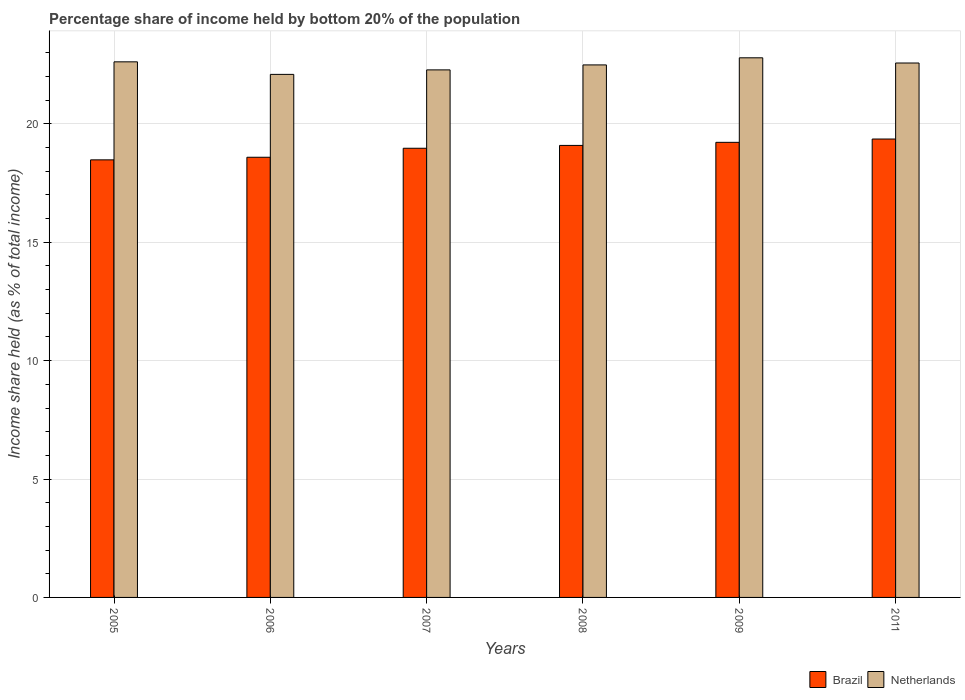How many groups of bars are there?
Provide a succinct answer. 6. Are the number of bars per tick equal to the number of legend labels?
Make the answer very short. Yes. Are the number of bars on each tick of the X-axis equal?
Your answer should be very brief. Yes. What is the label of the 2nd group of bars from the left?
Keep it short and to the point. 2006. In how many cases, is the number of bars for a given year not equal to the number of legend labels?
Provide a succinct answer. 0. What is the share of income held by bottom 20% of the population in Netherlands in 2011?
Make the answer very short. 22.57. Across all years, what is the maximum share of income held by bottom 20% of the population in Netherlands?
Ensure brevity in your answer.  22.79. Across all years, what is the minimum share of income held by bottom 20% of the population in Netherlands?
Your response must be concise. 22.09. In which year was the share of income held by bottom 20% of the population in Netherlands minimum?
Offer a terse response. 2006. What is the total share of income held by bottom 20% of the population in Brazil in the graph?
Provide a short and direct response. 113.71. What is the difference between the share of income held by bottom 20% of the population in Netherlands in 2007 and that in 2008?
Make the answer very short. -0.21. What is the difference between the share of income held by bottom 20% of the population in Netherlands in 2008 and the share of income held by bottom 20% of the population in Brazil in 2005?
Provide a short and direct response. 4.01. What is the average share of income held by bottom 20% of the population in Brazil per year?
Ensure brevity in your answer.  18.95. In how many years, is the share of income held by bottom 20% of the population in Brazil greater than 12 %?
Your response must be concise. 6. What is the ratio of the share of income held by bottom 20% of the population in Netherlands in 2005 to that in 2006?
Give a very brief answer. 1.02. Is the share of income held by bottom 20% of the population in Brazil in 2006 less than that in 2009?
Your answer should be compact. Yes. What is the difference between the highest and the second highest share of income held by bottom 20% of the population in Netherlands?
Make the answer very short. 0.17. What is the difference between the highest and the lowest share of income held by bottom 20% of the population in Netherlands?
Offer a very short reply. 0.7. In how many years, is the share of income held by bottom 20% of the population in Netherlands greater than the average share of income held by bottom 20% of the population in Netherlands taken over all years?
Your response must be concise. 4. What does the 2nd bar from the left in 2009 represents?
Provide a succinct answer. Netherlands. How many bars are there?
Offer a very short reply. 12. Are all the bars in the graph horizontal?
Keep it short and to the point. No. How many years are there in the graph?
Provide a short and direct response. 6. Does the graph contain grids?
Offer a very short reply. Yes. Where does the legend appear in the graph?
Ensure brevity in your answer.  Bottom right. How many legend labels are there?
Your answer should be very brief. 2. How are the legend labels stacked?
Give a very brief answer. Horizontal. What is the title of the graph?
Ensure brevity in your answer.  Percentage share of income held by bottom 20% of the population. Does "South Asia" appear as one of the legend labels in the graph?
Make the answer very short. No. What is the label or title of the X-axis?
Make the answer very short. Years. What is the label or title of the Y-axis?
Your answer should be very brief. Income share held (as % of total income). What is the Income share held (as % of total income) of Brazil in 2005?
Make the answer very short. 18.48. What is the Income share held (as % of total income) of Netherlands in 2005?
Give a very brief answer. 22.62. What is the Income share held (as % of total income) of Brazil in 2006?
Provide a succinct answer. 18.59. What is the Income share held (as % of total income) of Netherlands in 2006?
Your answer should be very brief. 22.09. What is the Income share held (as % of total income) in Brazil in 2007?
Offer a very short reply. 18.97. What is the Income share held (as % of total income) of Netherlands in 2007?
Your answer should be very brief. 22.28. What is the Income share held (as % of total income) of Brazil in 2008?
Your response must be concise. 19.09. What is the Income share held (as % of total income) in Netherlands in 2008?
Your answer should be very brief. 22.49. What is the Income share held (as % of total income) of Brazil in 2009?
Your answer should be compact. 19.22. What is the Income share held (as % of total income) of Netherlands in 2009?
Give a very brief answer. 22.79. What is the Income share held (as % of total income) of Brazil in 2011?
Make the answer very short. 19.36. What is the Income share held (as % of total income) of Netherlands in 2011?
Your response must be concise. 22.57. Across all years, what is the maximum Income share held (as % of total income) in Brazil?
Give a very brief answer. 19.36. Across all years, what is the maximum Income share held (as % of total income) in Netherlands?
Offer a terse response. 22.79. Across all years, what is the minimum Income share held (as % of total income) in Brazil?
Your response must be concise. 18.48. Across all years, what is the minimum Income share held (as % of total income) in Netherlands?
Make the answer very short. 22.09. What is the total Income share held (as % of total income) of Brazil in the graph?
Your response must be concise. 113.71. What is the total Income share held (as % of total income) of Netherlands in the graph?
Ensure brevity in your answer.  134.84. What is the difference between the Income share held (as % of total income) in Brazil in 2005 and that in 2006?
Keep it short and to the point. -0.11. What is the difference between the Income share held (as % of total income) of Netherlands in 2005 and that in 2006?
Provide a short and direct response. 0.53. What is the difference between the Income share held (as % of total income) of Brazil in 2005 and that in 2007?
Offer a terse response. -0.49. What is the difference between the Income share held (as % of total income) of Netherlands in 2005 and that in 2007?
Keep it short and to the point. 0.34. What is the difference between the Income share held (as % of total income) in Brazil in 2005 and that in 2008?
Your response must be concise. -0.61. What is the difference between the Income share held (as % of total income) in Netherlands in 2005 and that in 2008?
Offer a terse response. 0.13. What is the difference between the Income share held (as % of total income) in Brazil in 2005 and that in 2009?
Give a very brief answer. -0.74. What is the difference between the Income share held (as % of total income) in Netherlands in 2005 and that in 2009?
Offer a very short reply. -0.17. What is the difference between the Income share held (as % of total income) of Brazil in 2005 and that in 2011?
Your answer should be very brief. -0.88. What is the difference between the Income share held (as % of total income) in Netherlands in 2005 and that in 2011?
Offer a very short reply. 0.05. What is the difference between the Income share held (as % of total income) of Brazil in 2006 and that in 2007?
Make the answer very short. -0.38. What is the difference between the Income share held (as % of total income) in Netherlands in 2006 and that in 2007?
Your answer should be compact. -0.19. What is the difference between the Income share held (as % of total income) in Brazil in 2006 and that in 2008?
Give a very brief answer. -0.5. What is the difference between the Income share held (as % of total income) in Netherlands in 2006 and that in 2008?
Make the answer very short. -0.4. What is the difference between the Income share held (as % of total income) in Brazil in 2006 and that in 2009?
Make the answer very short. -0.63. What is the difference between the Income share held (as % of total income) of Netherlands in 2006 and that in 2009?
Your answer should be very brief. -0.7. What is the difference between the Income share held (as % of total income) of Brazil in 2006 and that in 2011?
Make the answer very short. -0.77. What is the difference between the Income share held (as % of total income) of Netherlands in 2006 and that in 2011?
Provide a short and direct response. -0.48. What is the difference between the Income share held (as % of total income) in Brazil in 2007 and that in 2008?
Your answer should be very brief. -0.12. What is the difference between the Income share held (as % of total income) of Netherlands in 2007 and that in 2008?
Your response must be concise. -0.21. What is the difference between the Income share held (as % of total income) of Brazil in 2007 and that in 2009?
Provide a short and direct response. -0.25. What is the difference between the Income share held (as % of total income) of Netherlands in 2007 and that in 2009?
Provide a short and direct response. -0.51. What is the difference between the Income share held (as % of total income) of Brazil in 2007 and that in 2011?
Keep it short and to the point. -0.39. What is the difference between the Income share held (as % of total income) in Netherlands in 2007 and that in 2011?
Ensure brevity in your answer.  -0.29. What is the difference between the Income share held (as % of total income) of Brazil in 2008 and that in 2009?
Provide a short and direct response. -0.13. What is the difference between the Income share held (as % of total income) of Brazil in 2008 and that in 2011?
Make the answer very short. -0.27. What is the difference between the Income share held (as % of total income) in Netherlands in 2008 and that in 2011?
Your response must be concise. -0.08. What is the difference between the Income share held (as % of total income) in Brazil in 2009 and that in 2011?
Keep it short and to the point. -0.14. What is the difference between the Income share held (as % of total income) of Netherlands in 2009 and that in 2011?
Offer a very short reply. 0.22. What is the difference between the Income share held (as % of total income) in Brazil in 2005 and the Income share held (as % of total income) in Netherlands in 2006?
Provide a succinct answer. -3.61. What is the difference between the Income share held (as % of total income) of Brazil in 2005 and the Income share held (as % of total income) of Netherlands in 2008?
Provide a succinct answer. -4.01. What is the difference between the Income share held (as % of total income) of Brazil in 2005 and the Income share held (as % of total income) of Netherlands in 2009?
Provide a short and direct response. -4.31. What is the difference between the Income share held (as % of total income) in Brazil in 2005 and the Income share held (as % of total income) in Netherlands in 2011?
Your answer should be very brief. -4.09. What is the difference between the Income share held (as % of total income) of Brazil in 2006 and the Income share held (as % of total income) of Netherlands in 2007?
Provide a short and direct response. -3.69. What is the difference between the Income share held (as % of total income) of Brazil in 2006 and the Income share held (as % of total income) of Netherlands in 2011?
Provide a short and direct response. -3.98. What is the difference between the Income share held (as % of total income) in Brazil in 2007 and the Income share held (as % of total income) in Netherlands in 2008?
Keep it short and to the point. -3.52. What is the difference between the Income share held (as % of total income) of Brazil in 2007 and the Income share held (as % of total income) of Netherlands in 2009?
Provide a succinct answer. -3.82. What is the difference between the Income share held (as % of total income) in Brazil in 2008 and the Income share held (as % of total income) in Netherlands in 2011?
Ensure brevity in your answer.  -3.48. What is the difference between the Income share held (as % of total income) of Brazil in 2009 and the Income share held (as % of total income) of Netherlands in 2011?
Provide a succinct answer. -3.35. What is the average Income share held (as % of total income) in Brazil per year?
Keep it short and to the point. 18.95. What is the average Income share held (as % of total income) of Netherlands per year?
Offer a terse response. 22.47. In the year 2005, what is the difference between the Income share held (as % of total income) in Brazil and Income share held (as % of total income) in Netherlands?
Your answer should be compact. -4.14. In the year 2007, what is the difference between the Income share held (as % of total income) in Brazil and Income share held (as % of total income) in Netherlands?
Your response must be concise. -3.31. In the year 2009, what is the difference between the Income share held (as % of total income) of Brazil and Income share held (as % of total income) of Netherlands?
Keep it short and to the point. -3.57. In the year 2011, what is the difference between the Income share held (as % of total income) in Brazil and Income share held (as % of total income) in Netherlands?
Offer a very short reply. -3.21. What is the ratio of the Income share held (as % of total income) in Netherlands in 2005 to that in 2006?
Provide a short and direct response. 1.02. What is the ratio of the Income share held (as % of total income) of Brazil in 2005 to that in 2007?
Make the answer very short. 0.97. What is the ratio of the Income share held (as % of total income) in Netherlands in 2005 to that in 2007?
Your response must be concise. 1.02. What is the ratio of the Income share held (as % of total income) in Netherlands in 2005 to that in 2008?
Provide a short and direct response. 1.01. What is the ratio of the Income share held (as % of total income) of Brazil in 2005 to that in 2009?
Provide a succinct answer. 0.96. What is the ratio of the Income share held (as % of total income) in Netherlands in 2005 to that in 2009?
Offer a terse response. 0.99. What is the ratio of the Income share held (as % of total income) of Brazil in 2005 to that in 2011?
Make the answer very short. 0.95. What is the ratio of the Income share held (as % of total income) of Netherlands in 2006 to that in 2007?
Keep it short and to the point. 0.99. What is the ratio of the Income share held (as % of total income) of Brazil in 2006 to that in 2008?
Keep it short and to the point. 0.97. What is the ratio of the Income share held (as % of total income) in Netherlands in 2006 to that in 2008?
Offer a terse response. 0.98. What is the ratio of the Income share held (as % of total income) of Brazil in 2006 to that in 2009?
Your response must be concise. 0.97. What is the ratio of the Income share held (as % of total income) of Netherlands in 2006 to that in 2009?
Ensure brevity in your answer.  0.97. What is the ratio of the Income share held (as % of total income) in Brazil in 2006 to that in 2011?
Provide a short and direct response. 0.96. What is the ratio of the Income share held (as % of total income) of Netherlands in 2006 to that in 2011?
Your response must be concise. 0.98. What is the ratio of the Income share held (as % of total income) of Netherlands in 2007 to that in 2008?
Provide a short and direct response. 0.99. What is the ratio of the Income share held (as % of total income) of Netherlands in 2007 to that in 2009?
Your response must be concise. 0.98. What is the ratio of the Income share held (as % of total income) of Brazil in 2007 to that in 2011?
Provide a succinct answer. 0.98. What is the ratio of the Income share held (as % of total income) in Netherlands in 2007 to that in 2011?
Your answer should be very brief. 0.99. What is the ratio of the Income share held (as % of total income) in Brazil in 2008 to that in 2009?
Give a very brief answer. 0.99. What is the ratio of the Income share held (as % of total income) of Netherlands in 2008 to that in 2009?
Provide a succinct answer. 0.99. What is the ratio of the Income share held (as % of total income) in Brazil in 2008 to that in 2011?
Give a very brief answer. 0.99. What is the ratio of the Income share held (as % of total income) of Netherlands in 2008 to that in 2011?
Make the answer very short. 1. What is the ratio of the Income share held (as % of total income) of Netherlands in 2009 to that in 2011?
Offer a very short reply. 1.01. What is the difference between the highest and the second highest Income share held (as % of total income) of Brazil?
Give a very brief answer. 0.14. What is the difference between the highest and the second highest Income share held (as % of total income) in Netherlands?
Offer a terse response. 0.17. What is the difference between the highest and the lowest Income share held (as % of total income) in Netherlands?
Offer a terse response. 0.7. 